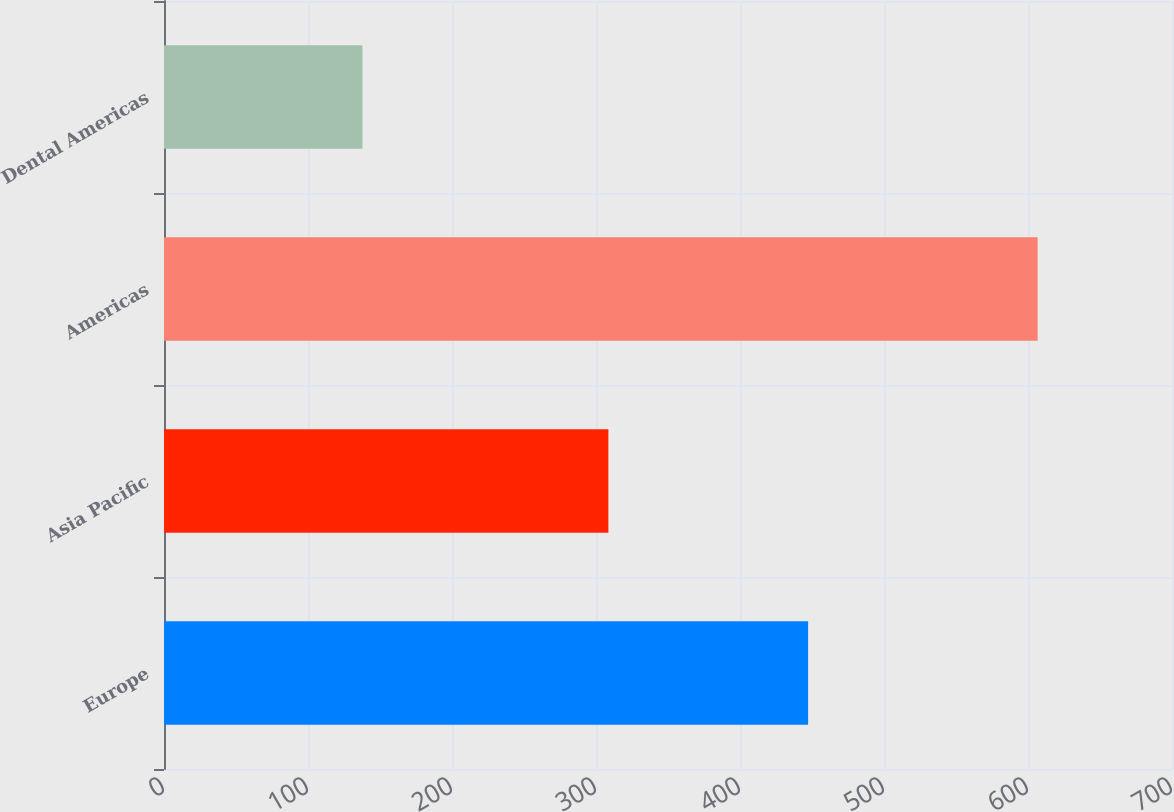<chart> <loc_0><loc_0><loc_500><loc_500><bar_chart><fcel>Europe<fcel>Asia Pacific<fcel>Americas<fcel>Dental Americas<nl><fcel>447.3<fcel>308.6<fcel>606.7<fcel>137.8<nl></chart> 